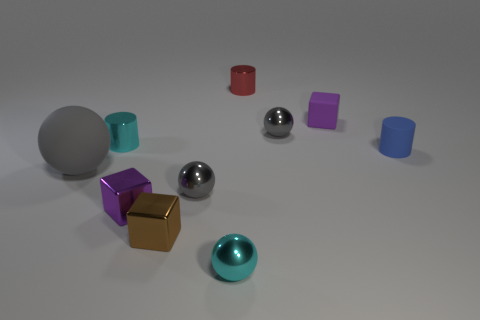What is the color distribution in the image? The image features a mix of colors including grey, brown, red, purple, silver, teal, and blue. These colors are distributed across different geometric shapes scattered over a light grey surface. 